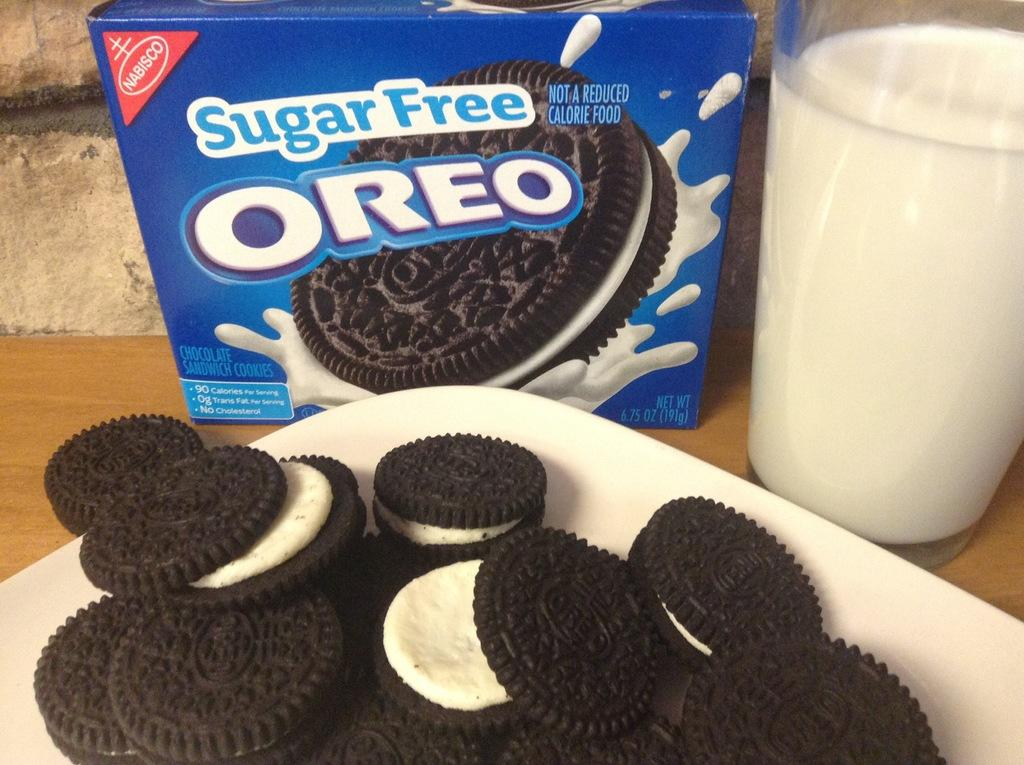What type of food is on the plate in the image? There are biscuits on a plate in the image. What is the container for the liquid in the image? There is a milk glass in the image. What else related to biscuits can be seen in the image? There is a biscuit packet on a surface in the image. What type of vest is being worn by the biscuits in the image? There are no biscuits or people wearing vests in the image. What knowledge can be gained from the biscuits in the image? The image does not convey any specific knowledge, as it is a simple depiction of biscuits and related items. 